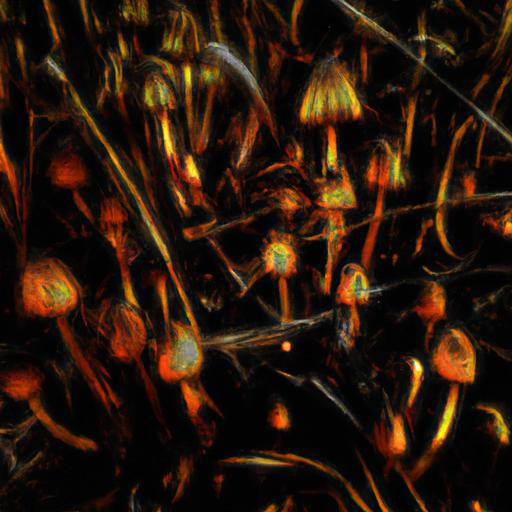Can you suggest a theme or story that this image might convey? This image could evoke the theme of natural wonder fused with fantasy. It might tell a story of an enchanted forest at night, where flora and fungi emit a bioluminescent glow, creating a mystical atmosphere of discovery and magic. 